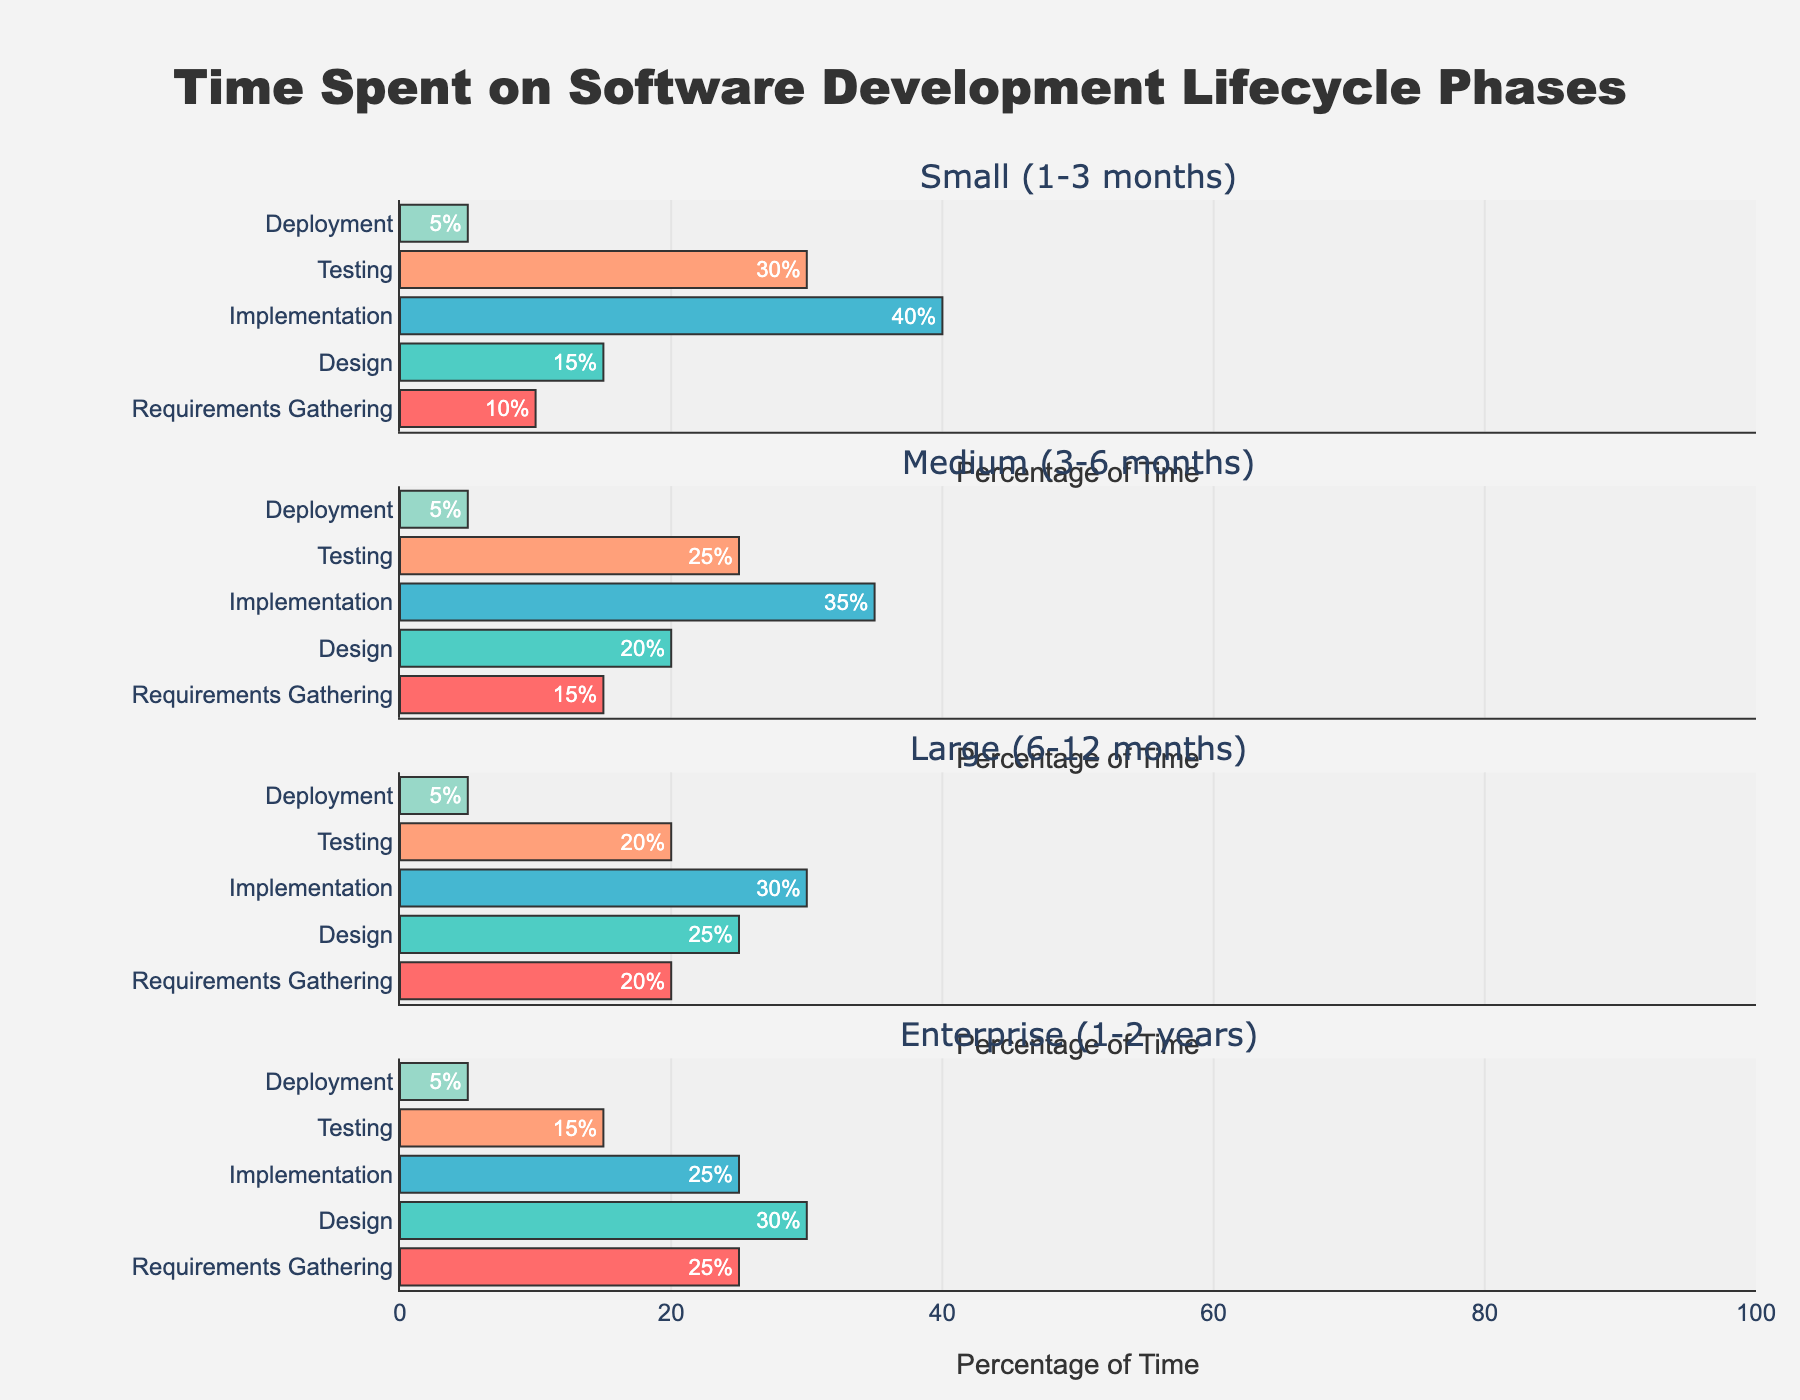What is the title of the figure? The title of the figure is stated at the top of the visual representation.
Answer: Time Spent on Software Development Lifecycle Phases How many phases of the software development lifecycle are considered in the figure? By looking at the x-axis labels on the individual horizontal bars, we can count 5 phases.
Answer: 5 Which project size spends the most percentage of time on the Implementation phase? By examining the horizontal bars corresponding to the Implementation phase across different project sizes, we see that "Small (1-3 months)" spends 40%, which is the most.
Answer: Small (1-3 months) What is the percentage difference in time spent on the Design phase between Medium (3-6 months) and Enterprise (1-2 years) projects? We can refer to the text labels on the bars for the Design phase in Medium and Enterprise project sizes, which are 20% and 30% respectively. The difference is 30% - 20% = 10%.
Answer: 10% In which phase is the percentage of time spent constant across all project sizes? By checking the text labels for each phase across all project sizes, we can see that Deployment remains constant at 5%.
Answer: Deployment For the Enterprise (1-2 years) project size, what is the total time percentage spent on Requirements Gathering and Testing combined? The text labels on the Enterprise project's bars for Requirements Gathering and Testing show 25% and 15% respectively. Their combined time is 25% + 15% = 40%.
Answer: 40% Which project size has the smallest percentage of time spent on Testing? From examining the horizontal bars of the Testing phase for all project sizes, "Enterprise (1-2 years)" has the smallest percentage at 15%.
Answer: Enterprise (1-2 years) How does the percentage of time spent on the Design phase evolve as the project size increases from Small to Enterprise? By reviewing the Design phase bars across project sizes (Small: 15%, Medium: 20%, Large: 25%, Enterprise: 30%), we see that the percentage increases progressively.
Answer: Increases Comparing Small (1-3 months) and Large (6-12 months) projects, which phase shows the highest difference in percentage time spent? By calculating the percentage differences for each phase between Small and Large projects (Requirements Gathering: 20%-10%, Design: 25%-15%, Implementation: 30%-40%, Testing: 20%-30%, Deployment remains 5% both), we see the highest difference is in the Implementation phase at 40% - 30% = 10%.
Answer: Implementation 